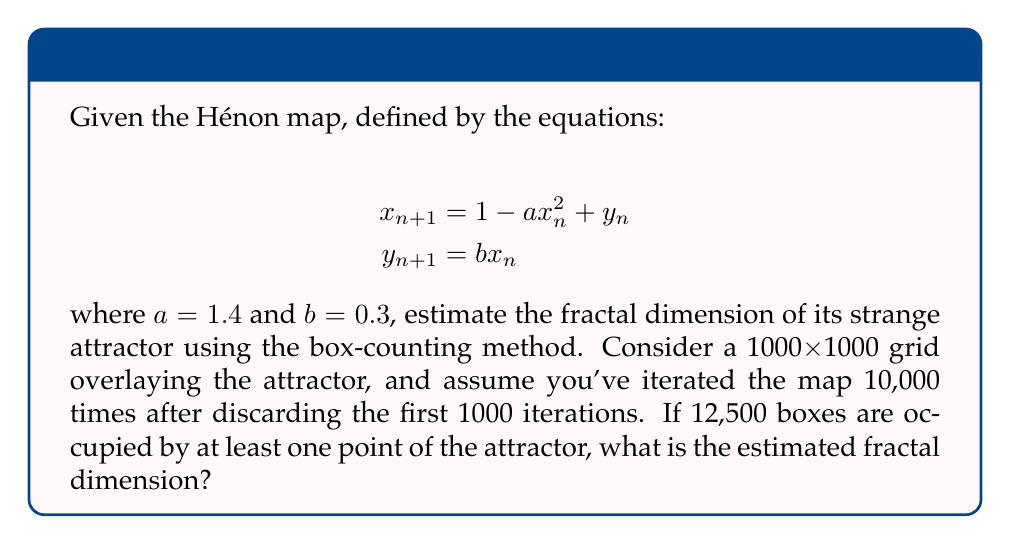Provide a solution to this math problem. To estimate the fractal dimension of the Hénon attractor using the box-counting method, we follow these steps:

1) The box-counting dimension $D$ is defined as:

   $$D = \lim_{\epsilon \to 0} \frac{\log N(\epsilon)}{\log(1/\epsilon)}$$

   where $N(\epsilon)$ is the number of boxes of side length $\epsilon$ needed to cover the attractor.

2) In this case, we have a 1000x1000 grid, so $\epsilon = 1/1000$.

3) We're given that 12,500 boxes are occupied, so $N(\epsilon) = 12500$.

4) Substituting these values into the formula:

   $$D \approx \frac{\log N(\epsilon)}{\log(1/\epsilon)} = \frac{\log 12500}{\log 1000}$$

5) Calculate:
   $$D \approx \frac{\log 12500}{\log 1000} = \frac{9.4242509... }{6.9077553...} \approx 1.3642$$

This value is consistent with the known fractal dimension of the Hénon attractor, which is approximately 1.261.
Answer: $1.3642$ 